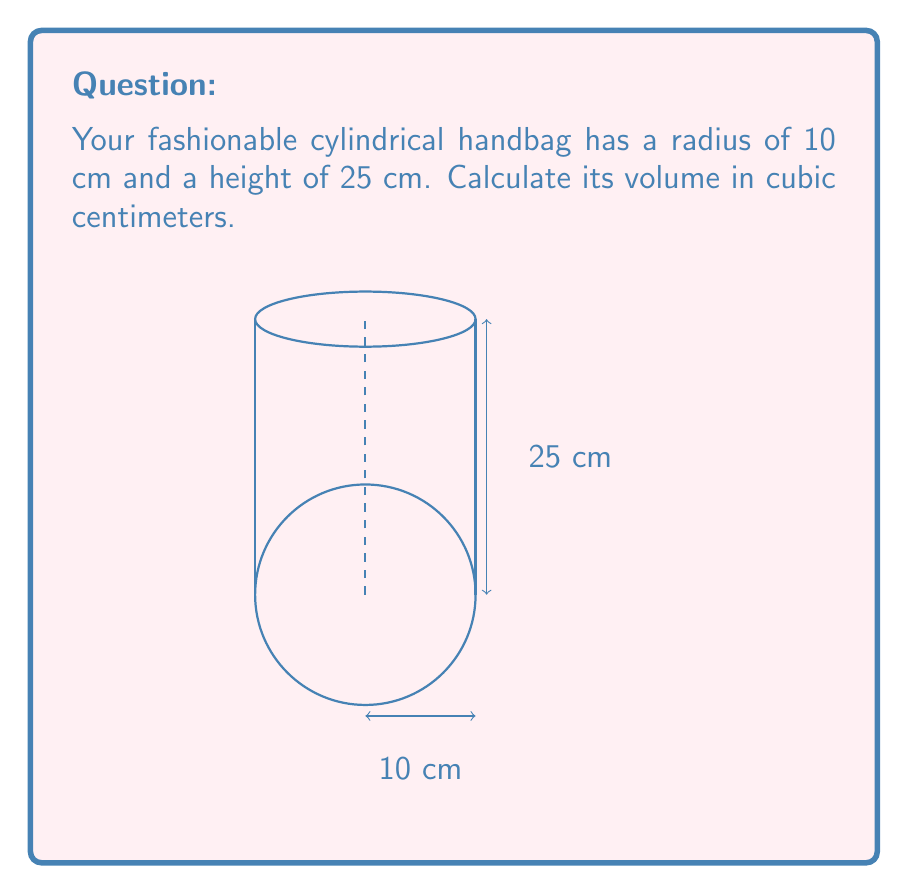Provide a solution to this math problem. To find the volume of a cylindrical handbag, we need to use the formula for the volume of a cylinder:

$$V = \pi r^2 h$$

Where:
$V$ = volume
$r$ = radius of the base
$h$ = height of the cylinder

Given:
$r = 10$ cm
$h = 25$ cm

Let's substitute these values into the formula:

$$\begin{align}
V &= \pi r^2 h \\
&= \pi \cdot (10\text{ cm})^2 \cdot 25\text{ cm} \\
&= \pi \cdot 100\text{ cm}^2 \cdot 25\text{ cm} \\
&= 2500\pi\text{ cm}^3 \\
&\approx 7853.98\text{ cm}^3
\end{align}$$

Rounding to the nearest whole number:

$$V \approx 7854\text{ cm}^3$$
Answer: $7854\text{ cm}^3$ 